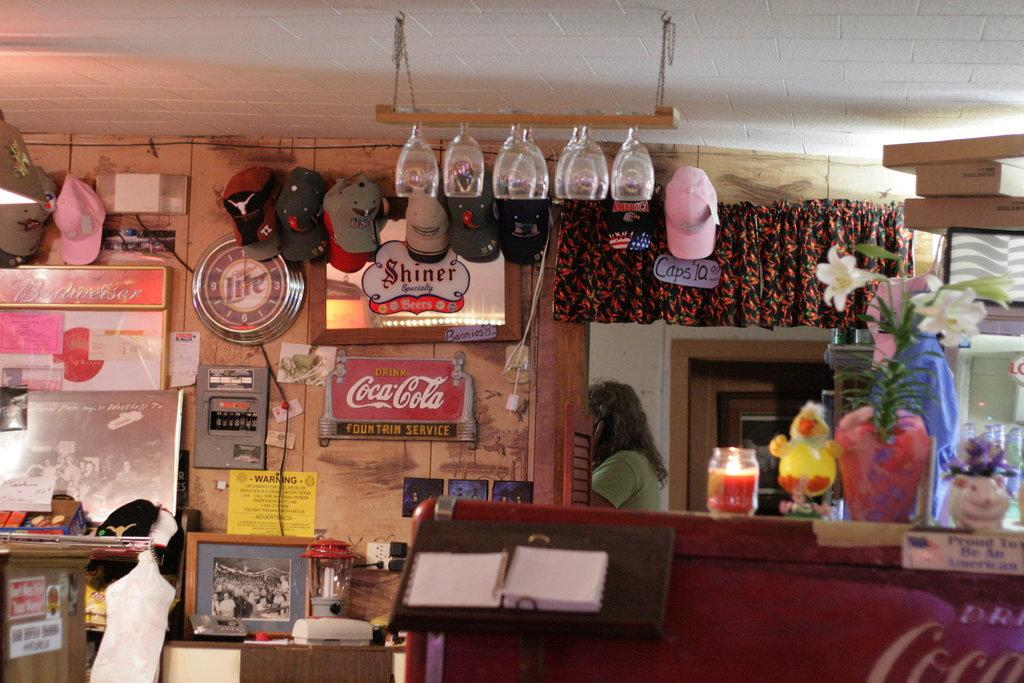Provide a one-sentence caption for the provided image. A Miller Lite clock is hanging near a Shiner sign. 